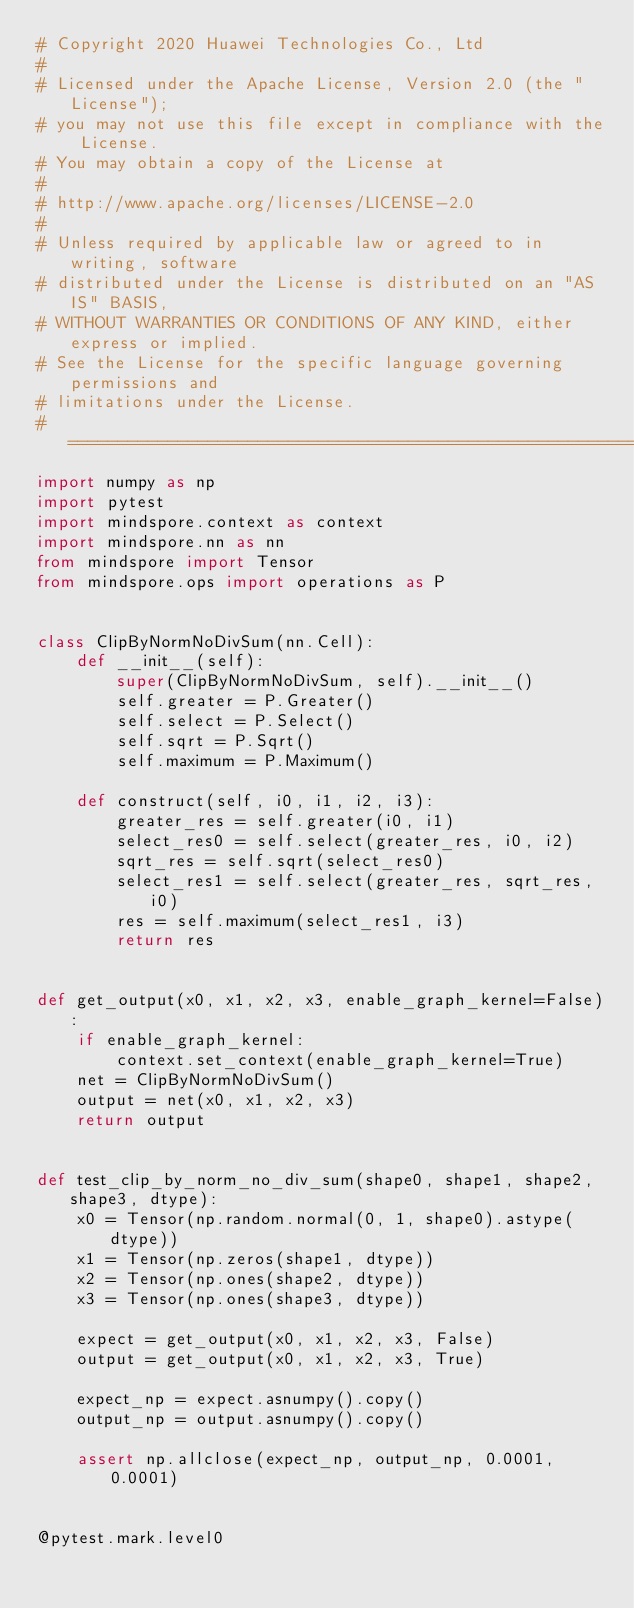Convert code to text. <code><loc_0><loc_0><loc_500><loc_500><_Python_># Copyright 2020 Huawei Technologies Co., Ltd
#
# Licensed under the Apache License, Version 2.0 (the "License");
# you may not use this file except in compliance with the License.
# You may obtain a copy of the License at
#
# http://www.apache.org/licenses/LICENSE-2.0
#
# Unless required by applicable law or agreed to in writing, software
# distributed under the License is distributed on an "AS IS" BASIS,
# WITHOUT WARRANTIES OR CONDITIONS OF ANY KIND, either express or implied.
# See the License for the specific language governing permissions and
# limitations under the License.
# ============================================================================
import numpy as np
import pytest
import mindspore.context as context
import mindspore.nn as nn
from mindspore import Tensor
from mindspore.ops import operations as P


class ClipByNormNoDivSum(nn.Cell):
    def __init__(self):
        super(ClipByNormNoDivSum, self).__init__()
        self.greater = P.Greater()
        self.select = P.Select()
        self.sqrt = P.Sqrt()
        self.maximum = P.Maximum()

    def construct(self, i0, i1, i2, i3):
        greater_res = self.greater(i0, i1)
        select_res0 = self.select(greater_res, i0, i2)
        sqrt_res = self.sqrt(select_res0)
        select_res1 = self.select(greater_res, sqrt_res, i0)
        res = self.maximum(select_res1, i3)
        return res


def get_output(x0, x1, x2, x3, enable_graph_kernel=False):
    if enable_graph_kernel:
        context.set_context(enable_graph_kernel=True)
    net = ClipByNormNoDivSum()
    output = net(x0, x1, x2, x3)
    return output


def test_clip_by_norm_no_div_sum(shape0, shape1, shape2, shape3, dtype):
    x0 = Tensor(np.random.normal(0, 1, shape0).astype(dtype))
    x1 = Tensor(np.zeros(shape1, dtype))
    x2 = Tensor(np.ones(shape2, dtype))
    x3 = Tensor(np.ones(shape3, dtype))

    expect = get_output(x0, x1, x2, x3, False)
    output = get_output(x0, x1, x2, x3, True)

    expect_np = expect.asnumpy().copy()
    output_np = output.asnumpy().copy()

    assert np.allclose(expect_np, output_np, 0.0001, 0.0001)


@pytest.mark.level0</code> 